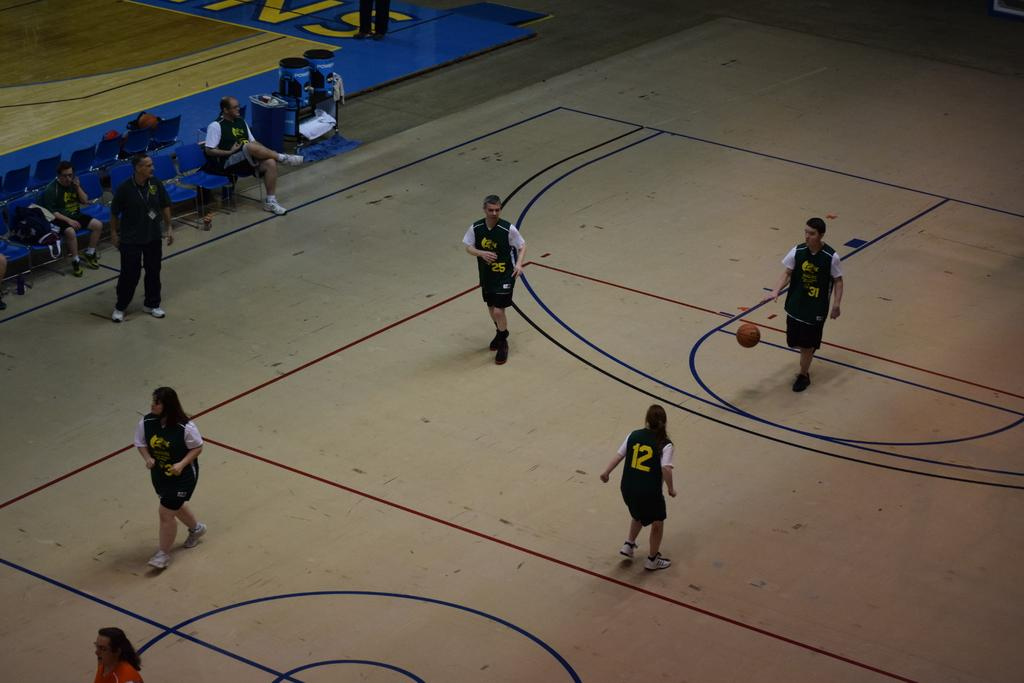<image>
Render a clear and concise summary of the photo. Number 12 playing defense on number 31 who is dribbling the ball. 